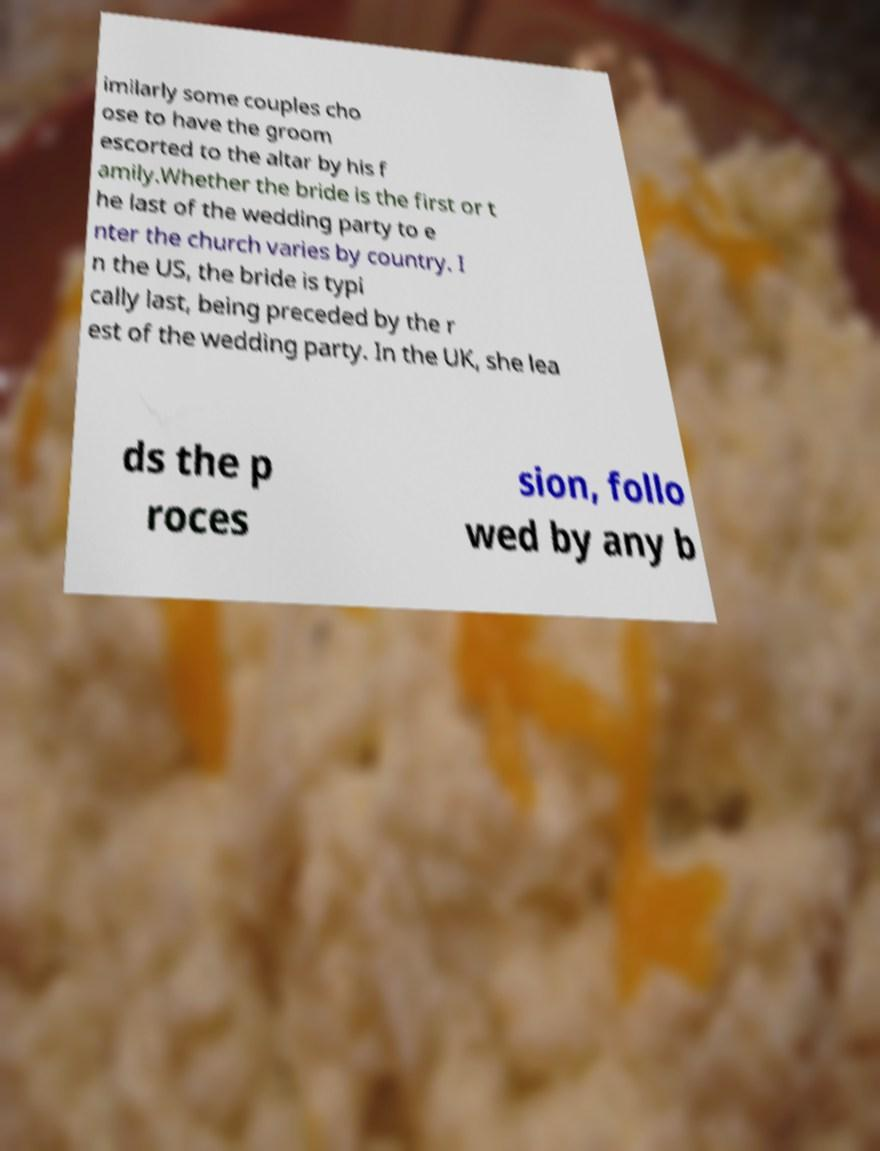Can you read and provide the text displayed in the image?This photo seems to have some interesting text. Can you extract and type it out for me? imilarly some couples cho ose to have the groom escorted to the altar by his f amily.Whether the bride is the first or t he last of the wedding party to e nter the church varies by country. I n the US, the bride is typi cally last, being preceded by the r est of the wedding party. In the UK, she lea ds the p roces sion, follo wed by any b 